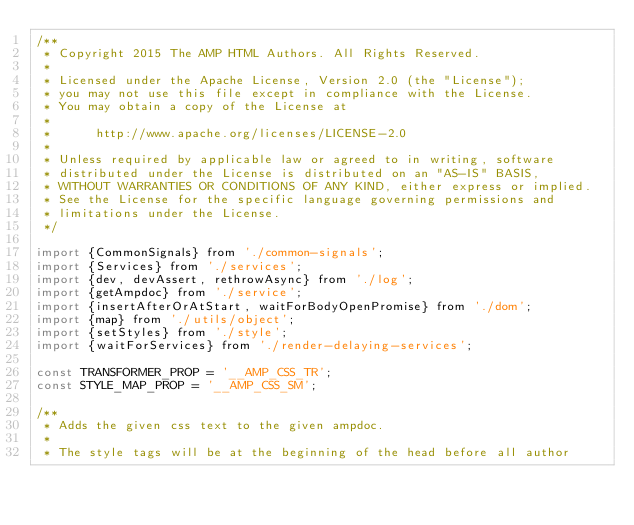<code> <loc_0><loc_0><loc_500><loc_500><_JavaScript_>/**
 * Copyright 2015 The AMP HTML Authors. All Rights Reserved.
 *
 * Licensed under the Apache License, Version 2.0 (the "License");
 * you may not use this file except in compliance with the License.
 * You may obtain a copy of the License at
 *
 *      http://www.apache.org/licenses/LICENSE-2.0
 *
 * Unless required by applicable law or agreed to in writing, software
 * distributed under the License is distributed on an "AS-IS" BASIS,
 * WITHOUT WARRANTIES OR CONDITIONS OF ANY KIND, either express or implied.
 * See the License for the specific language governing permissions and
 * limitations under the License.
 */

import {CommonSignals} from './common-signals';
import {Services} from './services';
import {dev, devAssert, rethrowAsync} from './log';
import {getAmpdoc} from './service';
import {insertAfterOrAtStart, waitForBodyOpenPromise} from './dom';
import {map} from './utils/object';
import {setStyles} from './style';
import {waitForServices} from './render-delaying-services';

const TRANSFORMER_PROP = '__AMP_CSS_TR';
const STYLE_MAP_PROP = '__AMP_CSS_SM';

/**
 * Adds the given css text to the given ampdoc.
 *
 * The style tags will be at the beginning of the head before all author</code> 